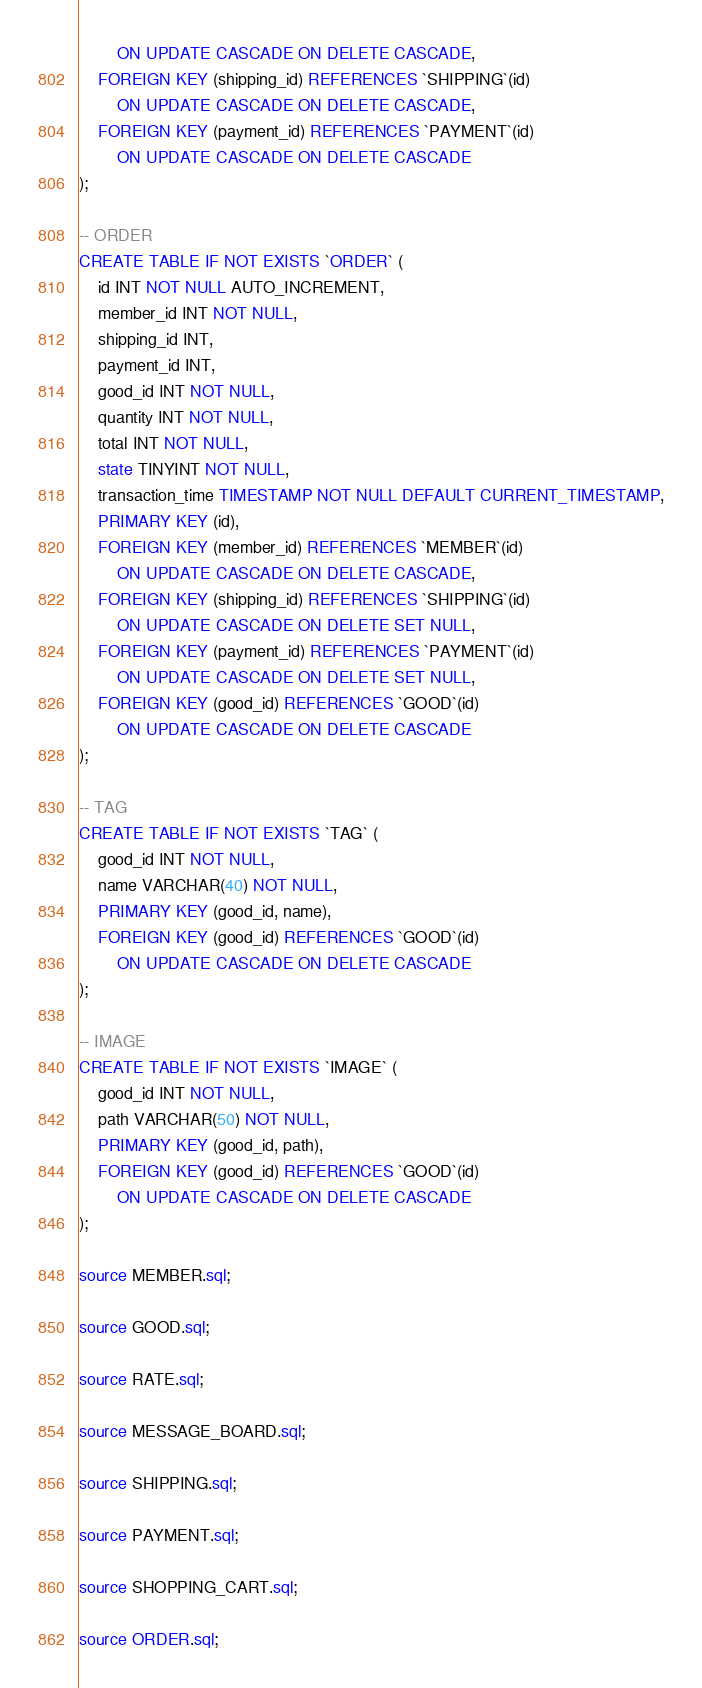<code> <loc_0><loc_0><loc_500><loc_500><_SQL_>        ON UPDATE CASCADE ON DELETE CASCADE,
    FOREIGN KEY (shipping_id) REFERENCES `SHIPPING`(id)
        ON UPDATE CASCADE ON DELETE CASCADE,
    FOREIGN KEY (payment_id) REFERENCES `PAYMENT`(id)
        ON UPDATE CASCADE ON DELETE CASCADE
);

-- ORDER
CREATE TABLE IF NOT EXISTS `ORDER` (
    id INT NOT NULL AUTO_INCREMENT,
    member_id INT NOT NULL,
    shipping_id INT,
    payment_id INT,
    good_id INT NOT NULL,
    quantity INT NOT NULL,
    total INT NOT NULL,
    state TINYINT NOT NULL,
    transaction_time TIMESTAMP NOT NULL DEFAULT CURRENT_TIMESTAMP,
    PRIMARY KEY (id),
    FOREIGN KEY (member_id) REFERENCES `MEMBER`(id)
        ON UPDATE CASCADE ON DELETE CASCADE,
    FOREIGN KEY (shipping_id) REFERENCES `SHIPPING`(id)
        ON UPDATE CASCADE ON DELETE SET NULL,
    FOREIGN KEY (payment_id) REFERENCES `PAYMENT`(id)
        ON UPDATE CASCADE ON DELETE SET NULL,
    FOREIGN KEY (good_id) REFERENCES `GOOD`(id)
        ON UPDATE CASCADE ON DELETE CASCADE
);

-- TAG
CREATE TABLE IF NOT EXISTS `TAG` (
    good_id INT NOT NULL,
    name VARCHAR(40) NOT NULL,
    PRIMARY KEY (good_id, name),
    FOREIGN KEY (good_id) REFERENCES `GOOD`(id)
        ON UPDATE CASCADE ON DELETE CASCADE
);

-- IMAGE
CREATE TABLE IF NOT EXISTS `IMAGE` (
    good_id INT NOT NULL,
    path VARCHAR(50) NOT NULL,
    PRIMARY KEY (good_id, path),
    FOREIGN KEY (good_id) REFERENCES `GOOD`(id)
        ON UPDATE CASCADE ON DELETE CASCADE
);

source MEMBER.sql;

source GOOD.sql;

source RATE.sql;

source MESSAGE_BOARD.sql;

source SHIPPING.sql;

source PAYMENT.sql;

source SHOPPING_CART.sql;

source ORDER.sql;
</code> 